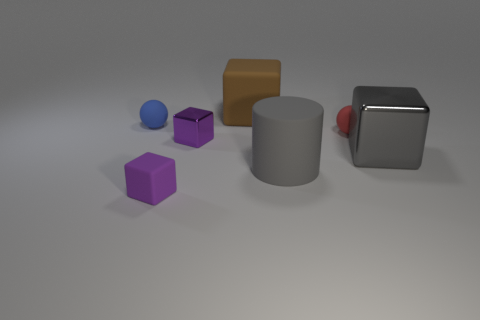Add 3 big cylinders. How many objects exist? 10 Subtract all cylinders. How many objects are left? 6 Add 2 small metallic things. How many small metallic things exist? 3 Subtract 1 blue balls. How many objects are left? 6 Subtract all tiny yellow metallic objects. Subtract all gray matte things. How many objects are left? 6 Add 3 red balls. How many red balls are left? 4 